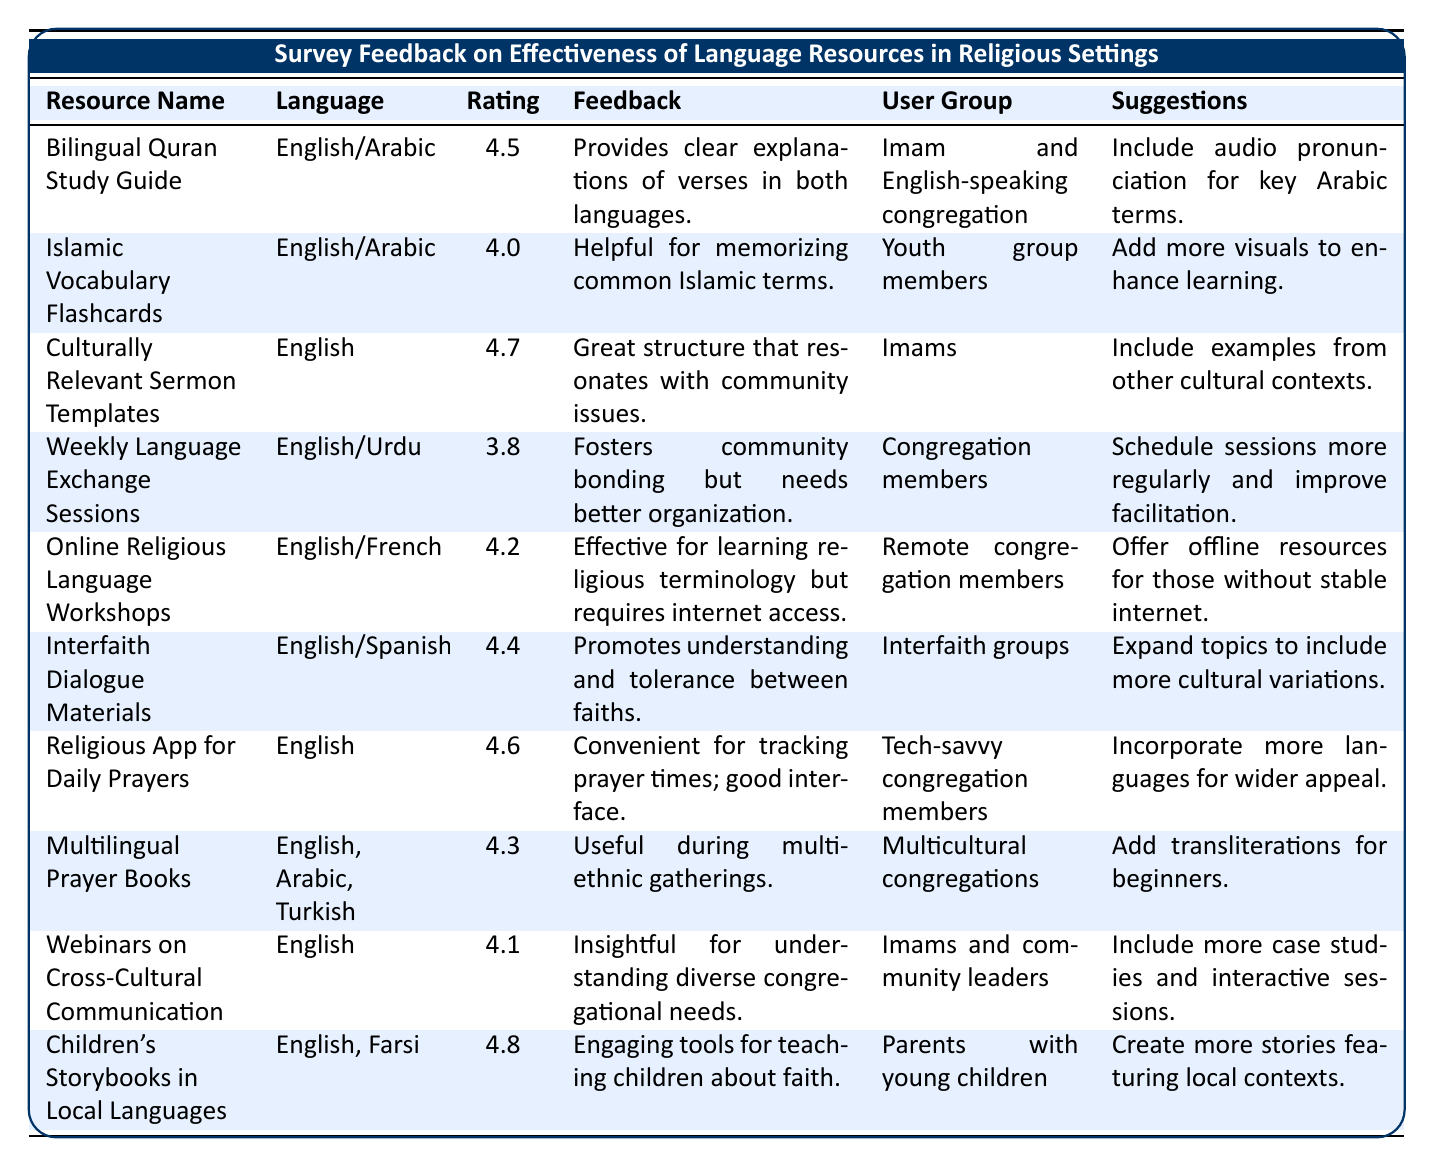What is the highest effectiveness rating given for any resource? The effectiveness ratings are: 4.5, 4.0, 4.7, 3.8, 4.2, 4.4, 4.6, 4.3, 4.1, and 4.8. The highest rating is 4.8 from Children's Storybooks in Local Languages.
Answer: 4.8 Which resource received feedback about needing better organization? The Weekly Language Exchange Sessions received feedback about needing better organization as indicated in the comments under feedback.
Answer: Weekly Language Exchange Sessions What is the average effectiveness rating for all resources mentioned? The ratings are 4.5, 4.0, 4.7, 3.8, 4.2, 4.4, 4.6, 4.3, 4.1, and 4.8. The total sum is 44.4, and dividing by 10 gives an average of 4.44.
Answer: 4.44 Did any resource focus solely on English language? Culturally Relevant Sermon Templates and Religious App for Daily Prayers focus solely on English.
Answer: Yes Which user group provided feedback on the Bilingual Quran Study Guide? The user group for the Bilingual Quran Study Guide is "Imam and English-speaking congregation" as listed in the table.
Answer: Imam and English-speaking congregation How many resources have an effectiveness rating above 4.5? The resources with ratings above 4.5 are: Bilingual Quran Study Guide (4.5), Culturally Relevant Sermon Templates (4.7), Religious App for Daily Prayers (4.6), and Children's Storybooks in Local Languages (4.8). That's 4 resources.
Answer: 4 Which language resource was suggested to include audio pronunciation? The Bilingual Quran Study Guide was suggested to include audio pronunciation for key Arabic terms.
Answer: Bilingual Quran Study Guide What percentage of resources are aimed at parents or youth? Two resources are aimed at parents (Children’s Storybooks in Local Languages) and youth (Islamic Vocabulary Flashcards) out of a total of 10. Thus, the percentage is (2/10)*100 = 20%.
Answer: 20% Identify a resource that promotes interfaith understanding. The Interfaith Dialogue Materials promote understanding and tolerance between faiths as mentioned in the feedback.
Answer: Interfaith Dialogue Materials Which resource was rated the lowest? The resource with the lowest rating is Weekly Language Exchange Sessions, with a score of 3.8.
Answer: Weekly Language Exchange Sessions 